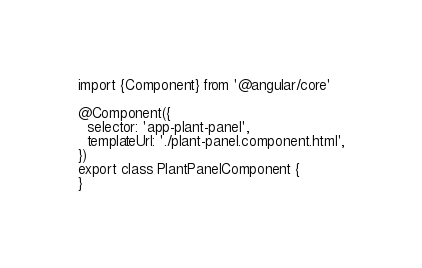<code> <loc_0><loc_0><loc_500><loc_500><_TypeScript_>import {Component} from '@angular/core'

@Component({
  selector: 'app-plant-panel',
  templateUrl: './plant-panel.component.html',
})
export class PlantPanelComponent {
}
</code> 